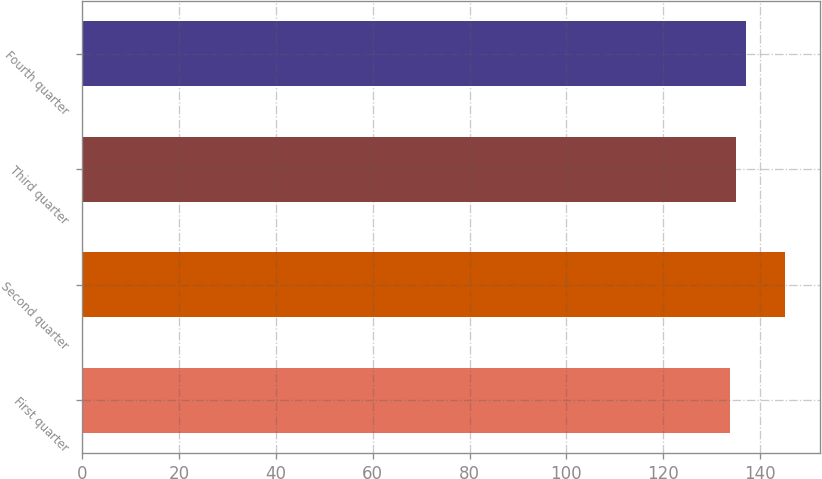Convert chart. <chart><loc_0><loc_0><loc_500><loc_500><bar_chart><fcel>First quarter<fcel>Second quarter<fcel>Third quarter<fcel>Fourth quarter<nl><fcel>133.82<fcel>145.13<fcel>134.95<fcel>137.1<nl></chart> 